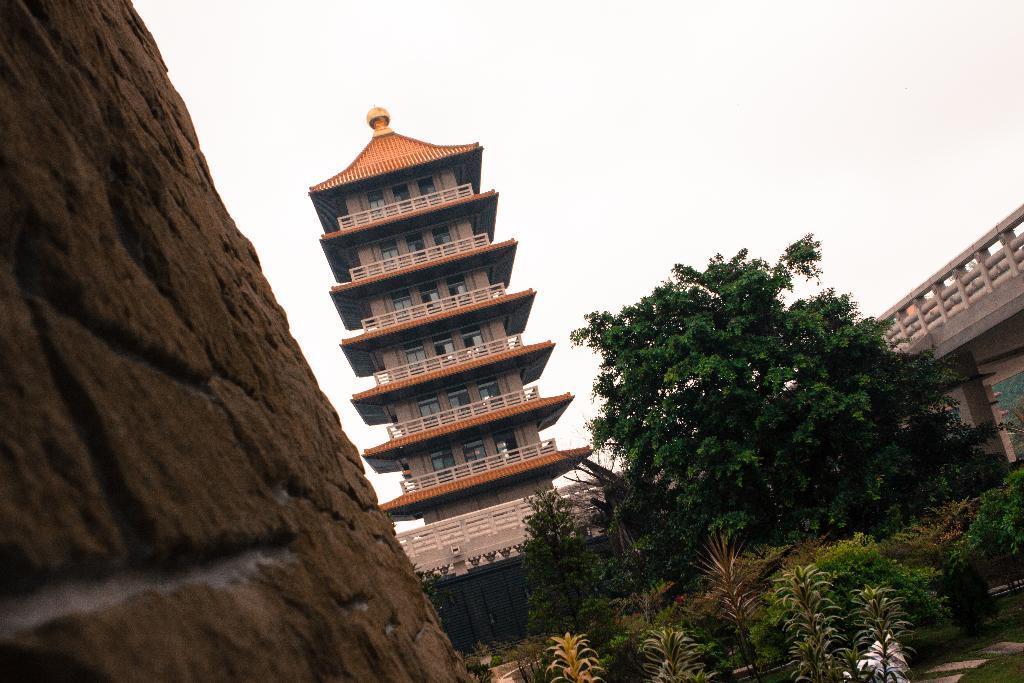Describe this image in one or two sentences. In this image we can see a building, few plants and trees, on the right side there is a bridge, on the left side there is a mountain. 